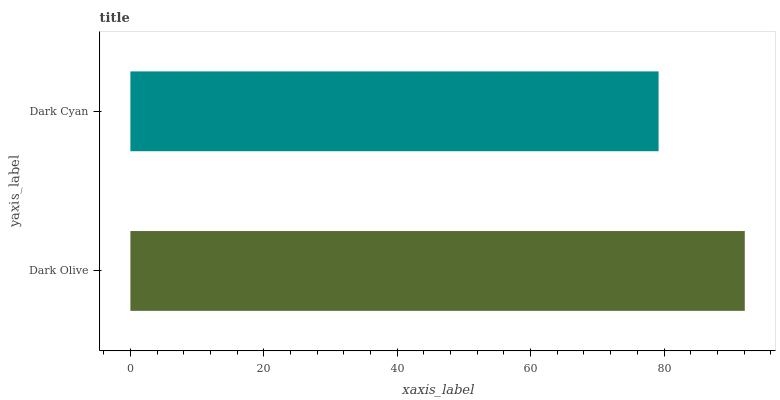Is Dark Cyan the minimum?
Answer yes or no. Yes. Is Dark Olive the maximum?
Answer yes or no. Yes. Is Dark Cyan the maximum?
Answer yes or no. No. Is Dark Olive greater than Dark Cyan?
Answer yes or no. Yes. Is Dark Cyan less than Dark Olive?
Answer yes or no. Yes. Is Dark Cyan greater than Dark Olive?
Answer yes or no. No. Is Dark Olive less than Dark Cyan?
Answer yes or no. No. Is Dark Olive the high median?
Answer yes or no. Yes. Is Dark Cyan the low median?
Answer yes or no. Yes. Is Dark Cyan the high median?
Answer yes or no. No. Is Dark Olive the low median?
Answer yes or no. No. 